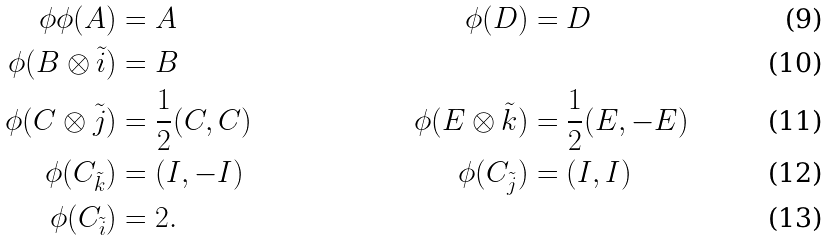<formula> <loc_0><loc_0><loc_500><loc_500>\phi \phi ( A ) & = A & \quad \phi ( D ) & = D \\ \phi ( B \otimes \tilde { i } ) & = B \\ \phi ( C \otimes \tilde { j } ) & = \frac { 1 } { 2 } ( C , C ) & \quad \phi ( E \otimes \tilde { k } ) & = \frac { 1 } { 2 } ( E , - E ) \\ \phi ( C _ { \tilde { k } } ) & = ( I , - I ) & \quad \phi ( C _ { \tilde { j } } ) & = ( I , I ) \\ \phi ( C _ { \tilde { i } } ) & = 2 .</formula> 